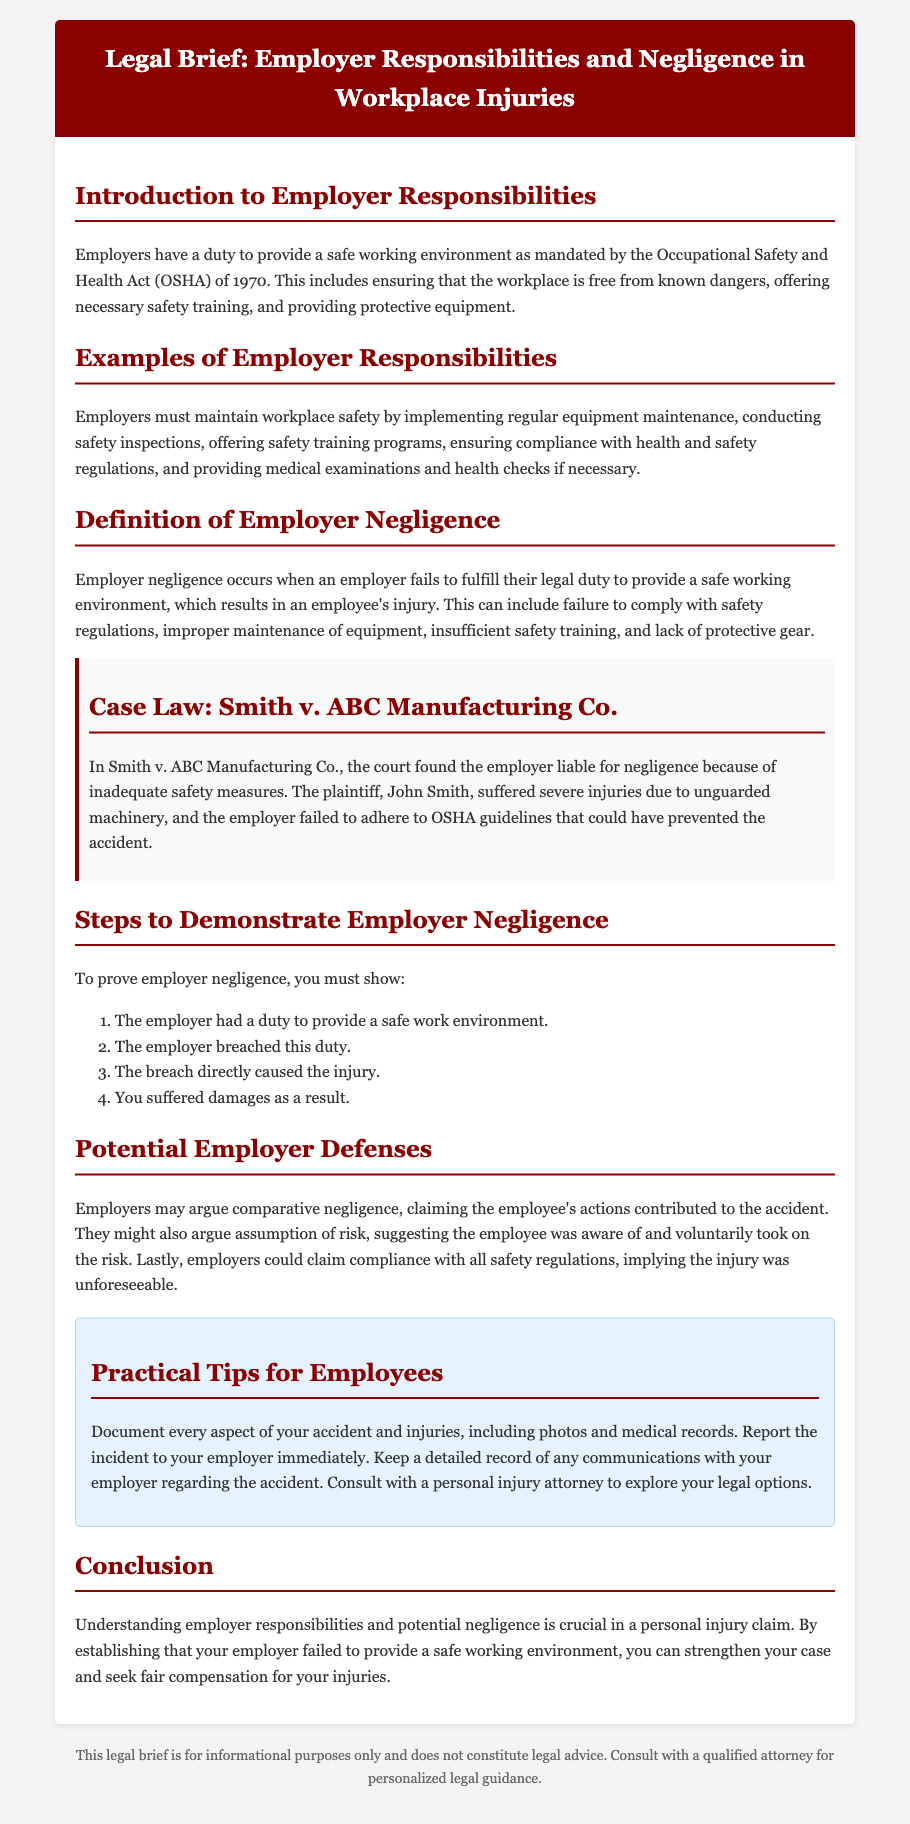What is the main law governing employer responsibilities? The main law is the Occupational Safety and Health Act (OSHA) of 1970.
Answer: Occupational Safety and Health Act (OSHA) of 1970 What must employers provide for a safe workplace? Employers must ensure the workplace is free from known dangers, offer safety training, and provide protective equipment.
Answer: Free from known dangers, safety training, protective equipment What is an example of employer negligence? An example of employer negligence is when an employer fails to comply with safety regulations.
Answer: Failure to comply with safety regulations In which case was an employer found liable for negligence? The case is Smith v. ABC Manufacturing Co.
Answer: Smith v. ABC Manufacturing Co What are the four steps to prove employer negligence? The steps include duty, breach, causation, and damages.
Answer: Duty, breach, causation, damages What might an employer argue if they claim the employee contributed to the accident? An employer might argue comparative negligence.
Answer: Comparative negligence What is one practical tip for employees after an accident? Employees should document every aspect of their accident and injuries.
Answer: Document every aspect of your accident and injuries What does the conclusion emphasize regarding employer responsibilities? The conclusion emphasizes the importance of understanding employer responsibilities and potential negligence in a personal injury claim.
Answer: Importance of understanding employer responsibilities and potential negligence 